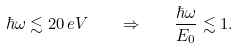Convert formula to latex. <formula><loc_0><loc_0><loc_500><loc_500>\hbar { \omega } \lesssim 2 0 \, e V \quad \Rightarrow \quad \frac { \hbar { \omega } } { E _ { 0 } } \lesssim 1 .</formula> 